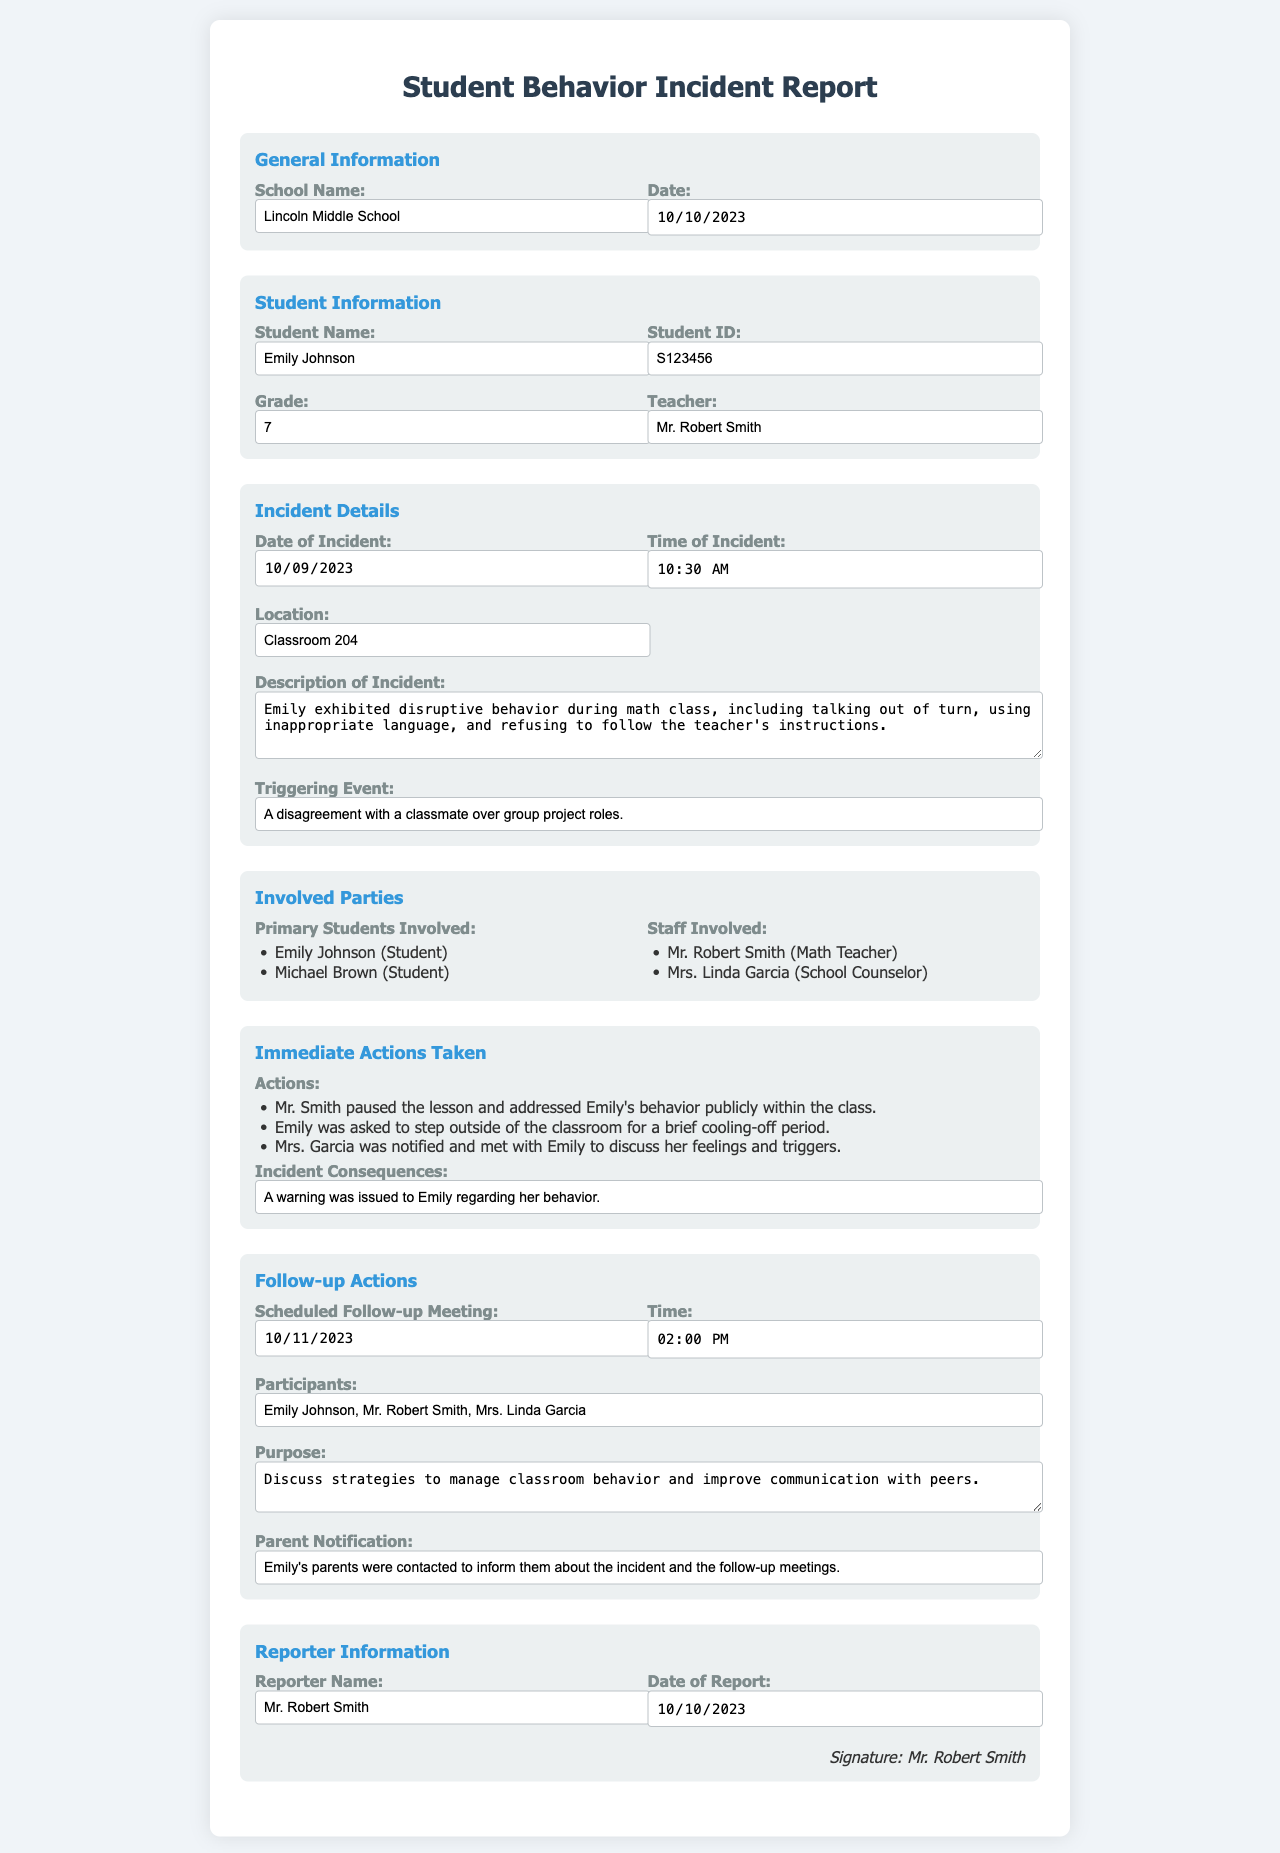What is the school name? The school name is listed in the general information section of the document.
Answer: Lincoln Middle School What is the date of the incident? The date of the incident is recorded in the incident details section.
Answer: 2023-10-09 Who is the primary student involved? The primary student involved is mentioned in the involved parties section.
Answer: Emily Johnson What time did the incident occur? The time of the incident is provided in the incident details section.
Answer: 10:30 What actions were taken immediately after the incident? Immediate actions taken are detailed under the immediate actions section.
Answer: Addressed behavior publicly, cooling-off period, met with counselor What is the purpose of the follow-up meeting? The purpose is outlined in the follow-up actions section regarding the meeting.
Answer: Discuss strategies to manage classroom behavior and improve communication with peers Who reported the incident? The reporter's name is found in the reporter information section.
Answer: Mr. Robert Smith What warning was issued as a consequence? The consequence for the incident is mentioned in the immediate actions section.
Answer: A warning was issued to Emily regarding her behavior When was the follow-up meeting scheduled? The date of the follow-up meeting is stated in the follow-up actions section.
Answer: 2023-10-11 